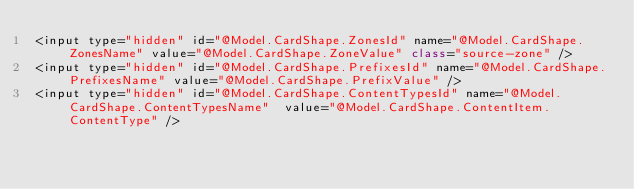Convert code to text. <code><loc_0><loc_0><loc_500><loc_500><_C#_><input type="hidden" id="@Model.CardShape.ZonesId" name="@Model.CardShape.ZonesName" value="@Model.CardShape.ZoneValue" class="source-zone" />
<input type="hidden" id="@Model.CardShape.PrefixesId" name="@Model.CardShape.PrefixesName" value="@Model.CardShape.PrefixValue" />
<input type="hidden" id="@Model.CardShape.ContentTypesId" name="@Model.CardShape.ContentTypesName"  value="@Model.CardShape.ContentItem.ContentType" />
</code> 